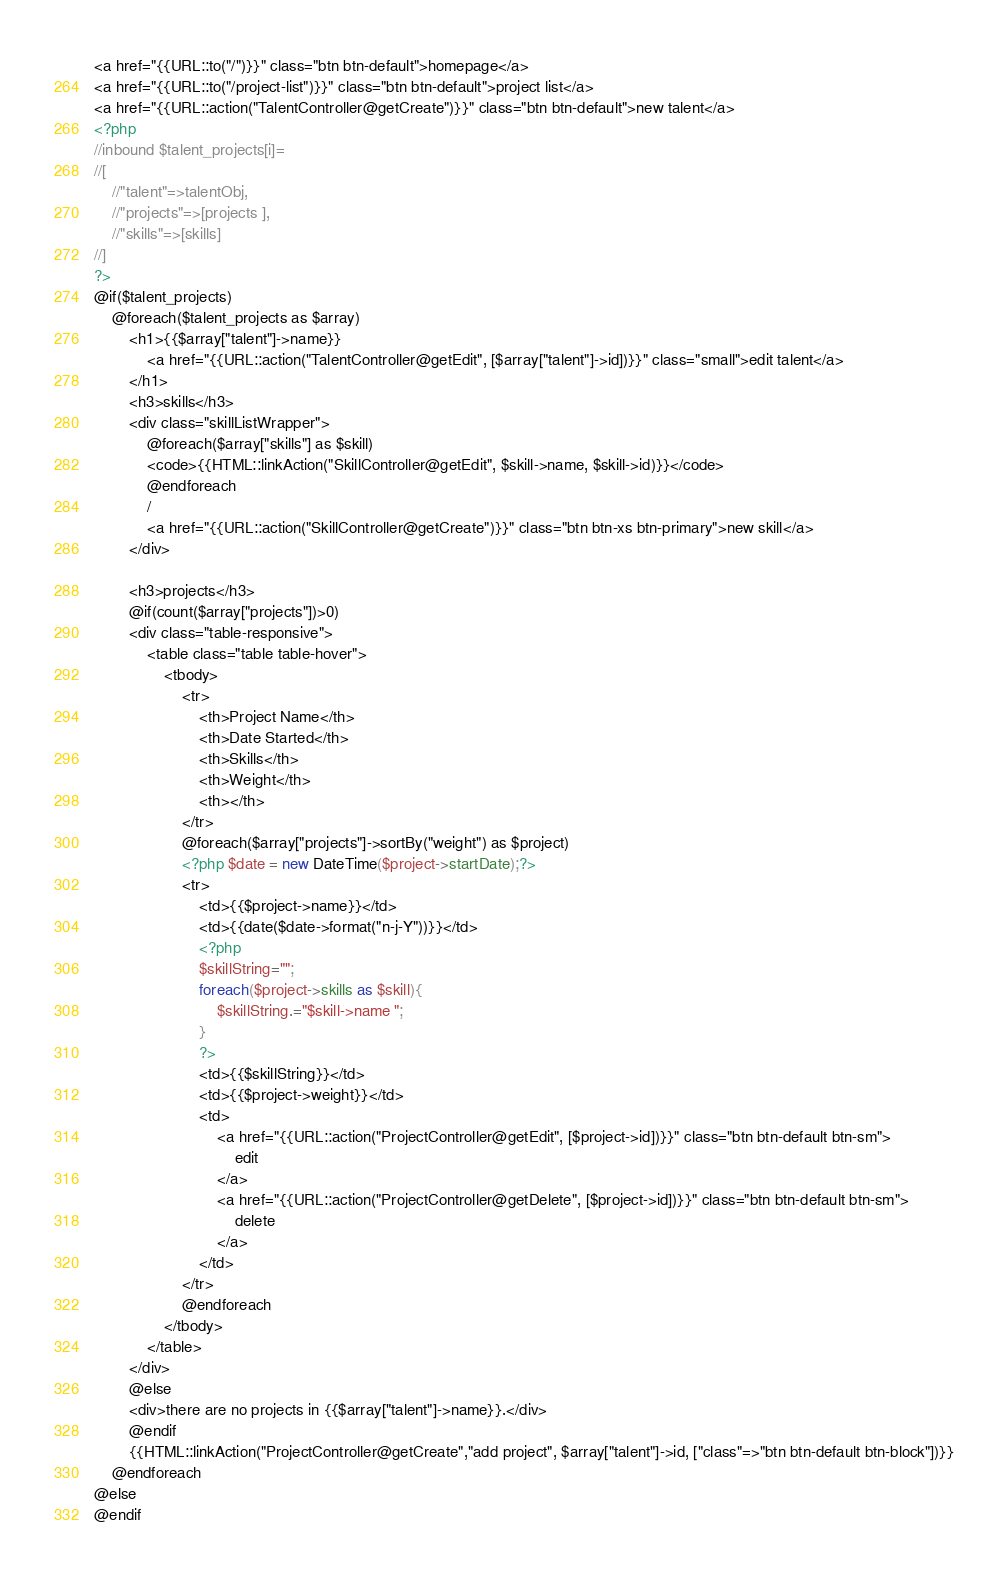<code> <loc_0><loc_0><loc_500><loc_500><_PHP_><a href="{{URL::to("/")}}" class="btn btn-default">homepage</a>
<a href="{{URL::to("/project-list")}}" class="btn btn-default">project list</a>
<a href="{{URL::action("TalentController@getCreate")}}" class="btn btn-default">new talent</a>
<?php
//inbound $talent_projects[i]=
//[ 
    //"talent"=>talentObj, 
    //"projects"=>[projects ], 
    //"skills"=>[skills] 
//]
?>
@if($talent_projects)
    @foreach($talent_projects as $array)
        <h1>{{$array["talent"]->name}} 
            <a href="{{URL::action("TalentController@getEdit", [$array["talent"]->id])}}" class="small">edit talent</a>
        </h1>
        <h3>skills</h3>
        <div class="skillListWrapper">
            @foreach($array["skills"] as $skill)
            <code>{{HTML::linkAction("SkillController@getEdit", $skill->name, $skill->id)}}</code>
            @endforeach
            /
            <a href="{{URL::action("SkillController@getCreate")}}" class="btn btn-xs btn-primary">new skill</a>
        </div>
        
        <h3>projects</h3>
        @if(count($array["projects"])>0)
        <div class="table-responsive">
            <table class="table table-hover">
                <tbody>
                    <tr>
                        <th>Project Name</th>
                        <th>Date Started</th>
                        <th>Skills</th>
                        <th>Weight</th>
                        <th></th>
                    </tr>
                    @foreach($array["projects"]->sortBy("weight") as $project)
                    <?php $date = new DateTime($project->startDate);?>
                    <tr>
                        <td>{{$project->name}}</td>
                        <td>{{date($date->format("n-j-Y"))}}</td>
                        <?php
                        $skillString="";
                        foreach($project->skills as $skill){
                            $skillString.="$skill->name ";
                        }
                        ?>
                        <td>{{$skillString}}</td>
                        <td>{{$project->weight}}</td>
                        <td>
                            <a href="{{URL::action("ProjectController@getEdit", [$project->id])}}" class="btn btn-default btn-sm">
                                edit
                            </a>
                            <a href="{{URL::action("ProjectController@getDelete", [$project->id])}}" class="btn btn-default btn-sm">
                                delete
                            </a>
                        </td>
                    </tr>
                    @endforeach
                </tbody> 
            </table>
        </div>  
        @else
        <div>there are no projects in {{$array["talent"]->name}}.</div>
        @endif
        {{HTML::linkAction("ProjectController@getCreate","add project", $array["talent"]->id, ["class"=>"btn btn-default btn-block"])}}
    @endforeach
@else
@endif</code> 